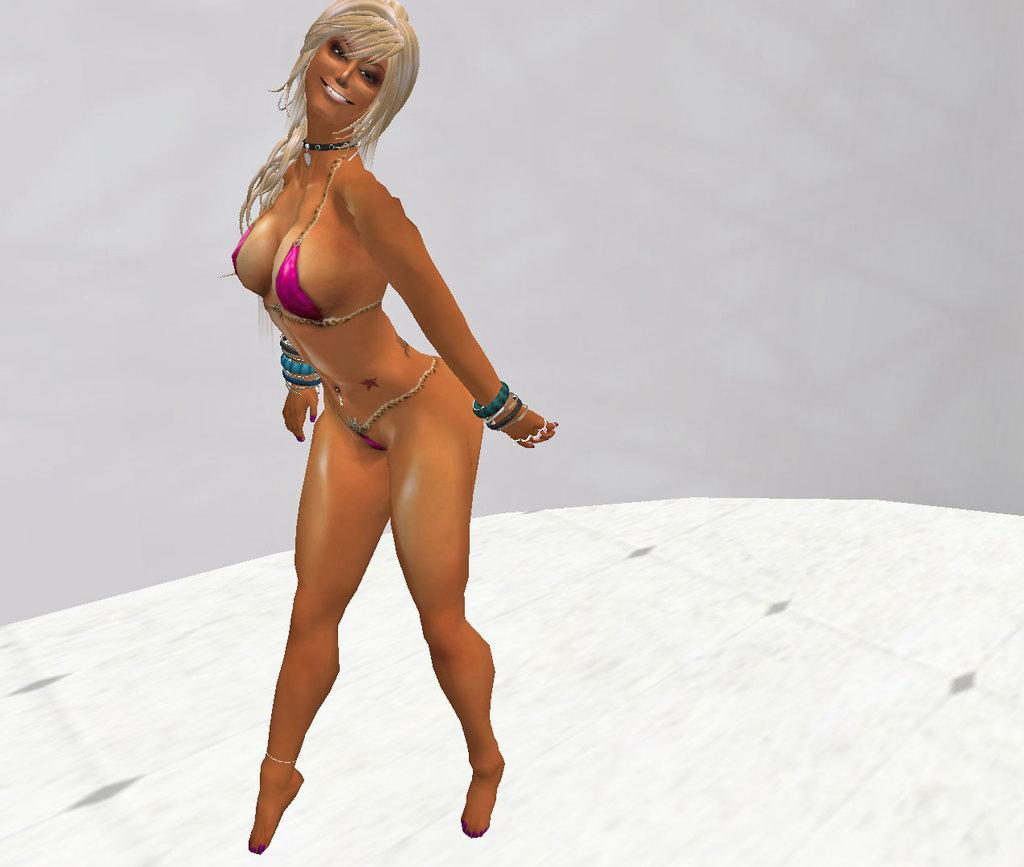What type of character is in the image? There is a cartoon woman in the image. What is the cartoon woman doing in the image? The cartoon woman is standing and giving a pose. What is the background of the image? There is a white background in the image. What type of prose is the cartoon woman reciting in the image? There is no indication in the image that the cartoon woman is reciting any prose. 